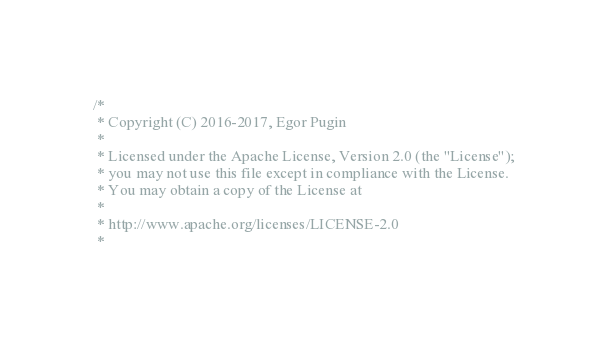<code> <loc_0><loc_0><loc_500><loc_500><_C++_>/*
 * Copyright (C) 2016-2017, Egor Pugin
 *
 * Licensed under the Apache License, Version 2.0 (the "License");
 * you may not use this file except in compliance with the License.
 * You may obtain a copy of the License at
 *
 * http://www.apache.org/licenses/LICENSE-2.0
 *</code> 